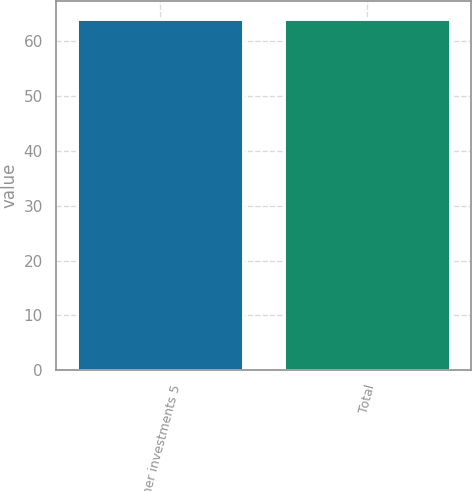<chart> <loc_0><loc_0><loc_500><loc_500><bar_chart><fcel>Other investments 5<fcel>Total<nl><fcel>64<fcel>64.1<nl></chart> 